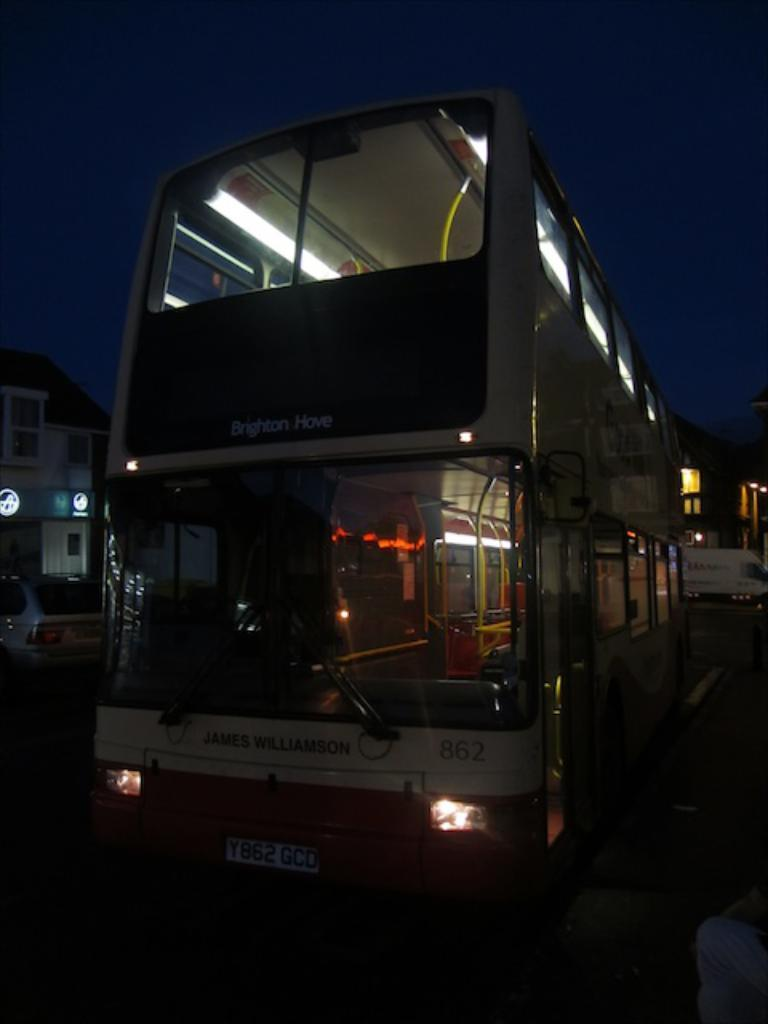What can be seen on the road in the image? There are vehicles on the road in the image. What is visible in the background of the image? There are buildings, boards, lights, and the sky visible in the background of the image. Can you see a boy swimming in the image? There is no boy swimming in the image. What type of beam is holding up the buildings in the image? The image does not provide information about the type of beams used in the buildings. 